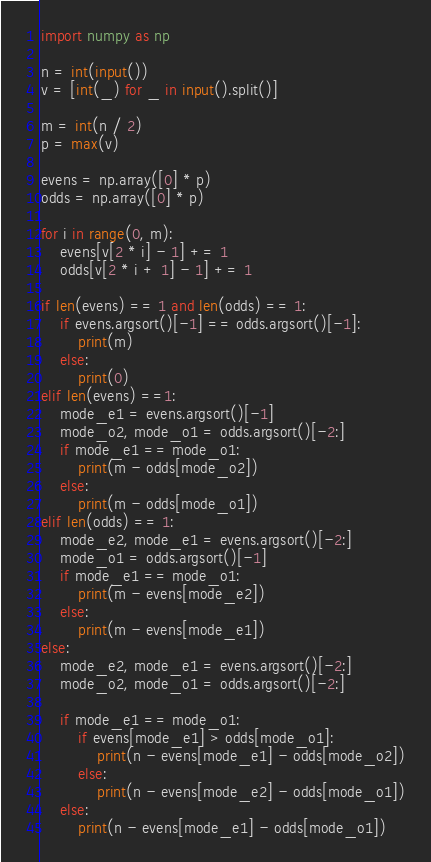<code> <loc_0><loc_0><loc_500><loc_500><_Python_>import numpy as np

n = int(input())
v = [int(_) for _ in input().split()]

m = int(n / 2)
p = max(v)

evens = np.array([0] * p)
odds = np.array([0] * p)

for i in range(0, m):
    evens[v[2 * i] - 1] += 1
    odds[v[2 * i + 1] - 1] += 1

if len(evens) == 1 and len(odds) == 1:
    if evens.argsort()[-1] == odds.argsort()[-1]:
        print(m)
    else:
        print(0)
elif len(evens) ==1:
    mode_e1 = evens.argsort()[-1]
    mode_o2, mode_o1 = odds.argsort()[-2:]
    if mode_e1 == mode_o1:
        print(m - odds[mode_o2])
    else:
        print(m - odds[mode_o1])
elif len(odds) == 1:
    mode_e2, mode_e1 = evens.argsort()[-2:]
    mode_o1 = odds.argsort()[-1]
    if mode_e1 == mode_o1:
        print(m - evens[mode_e2])
    else:
        print(m - evens[mode_e1])
else:
    mode_e2, mode_e1 = evens.argsort()[-2:]
    mode_o2, mode_o1 = odds.argsort()[-2:]

    if mode_e1 == mode_o1:
        if evens[mode_e1] > odds[mode_o1]:
            print(n - evens[mode_e1] - odds[mode_o2])
        else:
            print(n - evens[mode_e2] - odds[mode_o1])
    else:
        print(n - evens[mode_e1] - odds[mode_o1])</code> 